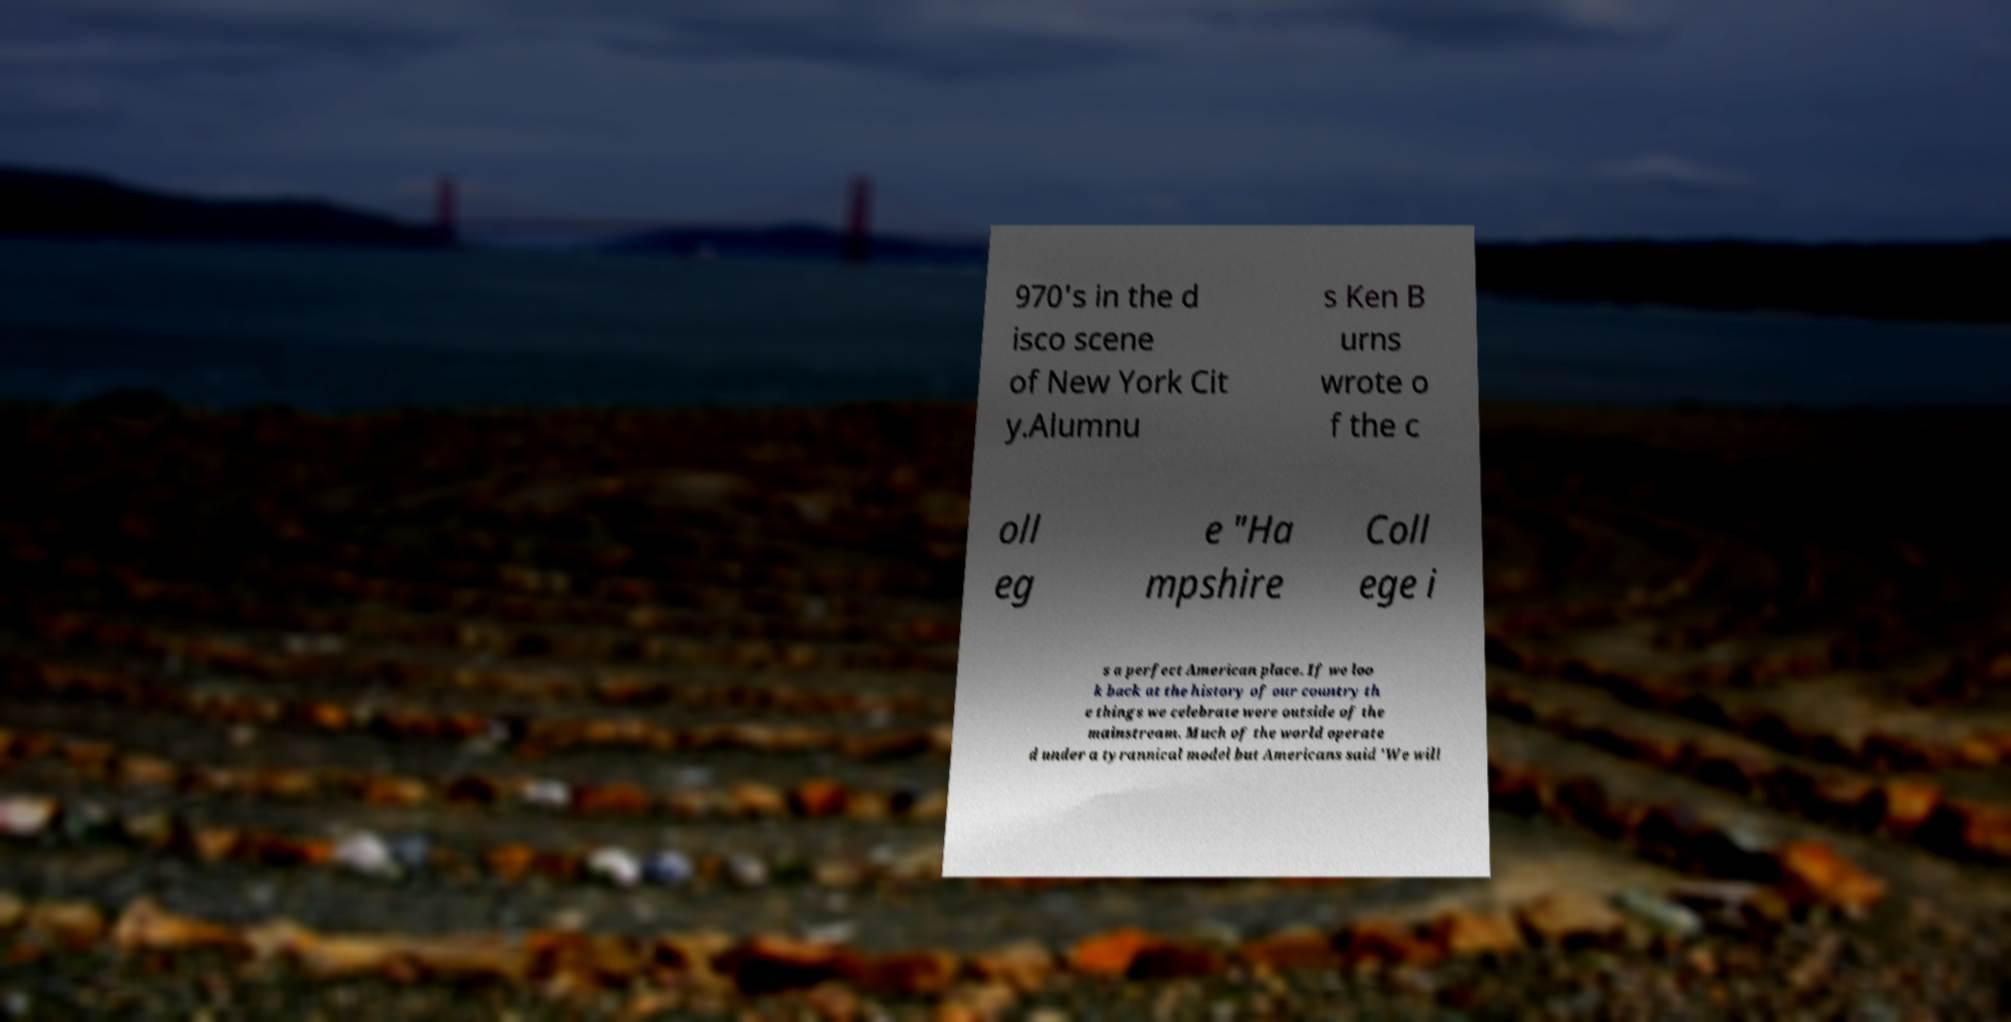I need the written content from this picture converted into text. Can you do that? 970's in the d isco scene of New York Cit y.Alumnu s Ken B urns wrote o f the c oll eg e "Ha mpshire Coll ege i s a perfect American place. If we loo k back at the history of our country th e things we celebrate were outside of the mainstream. Much of the world operate d under a tyrannical model but Americans said 'We will 